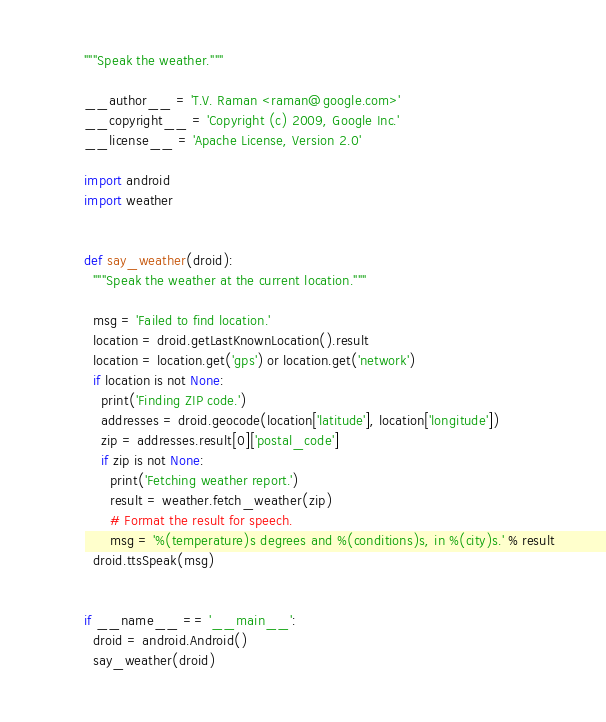Convert code to text. <code><loc_0><loc_0><loc_500><loc_500><_Python_>"""Speak the weather."""

__author__ = 'T.V. Raman <raman@google.com>'
__copyright__ = 'Copyright (c) 2009, Google Inc.'
__license__ = 'Apache License, Version 2.0'

import android
import weather


def say_weather(droid):
  """Speak the weather at the current location."""
  
  msg = 'Failed to find location.'
  location = droid.getLastKnownLocation().result
  location = location.get('gps') or location.get('network')
  if location is not None:
    print('Finding ZIP code.')
    addresses = droid.geocode(location['latitude'], location['longitude'])
    zip = addresses.result[0]['postal_code']
    if zip is not None:
      print('Fetching weather report.')
      result = weather.fetch_weather(zip)
      # Format the result for speech.
      msg = '%(temperature)s degrees and %(conditions)s, in %(city)s.' % result
  droid.ttsSpeak(msg)


if __name__ == '__main__':
  droid = android.Android()
  say_weather(droid)
</code> 